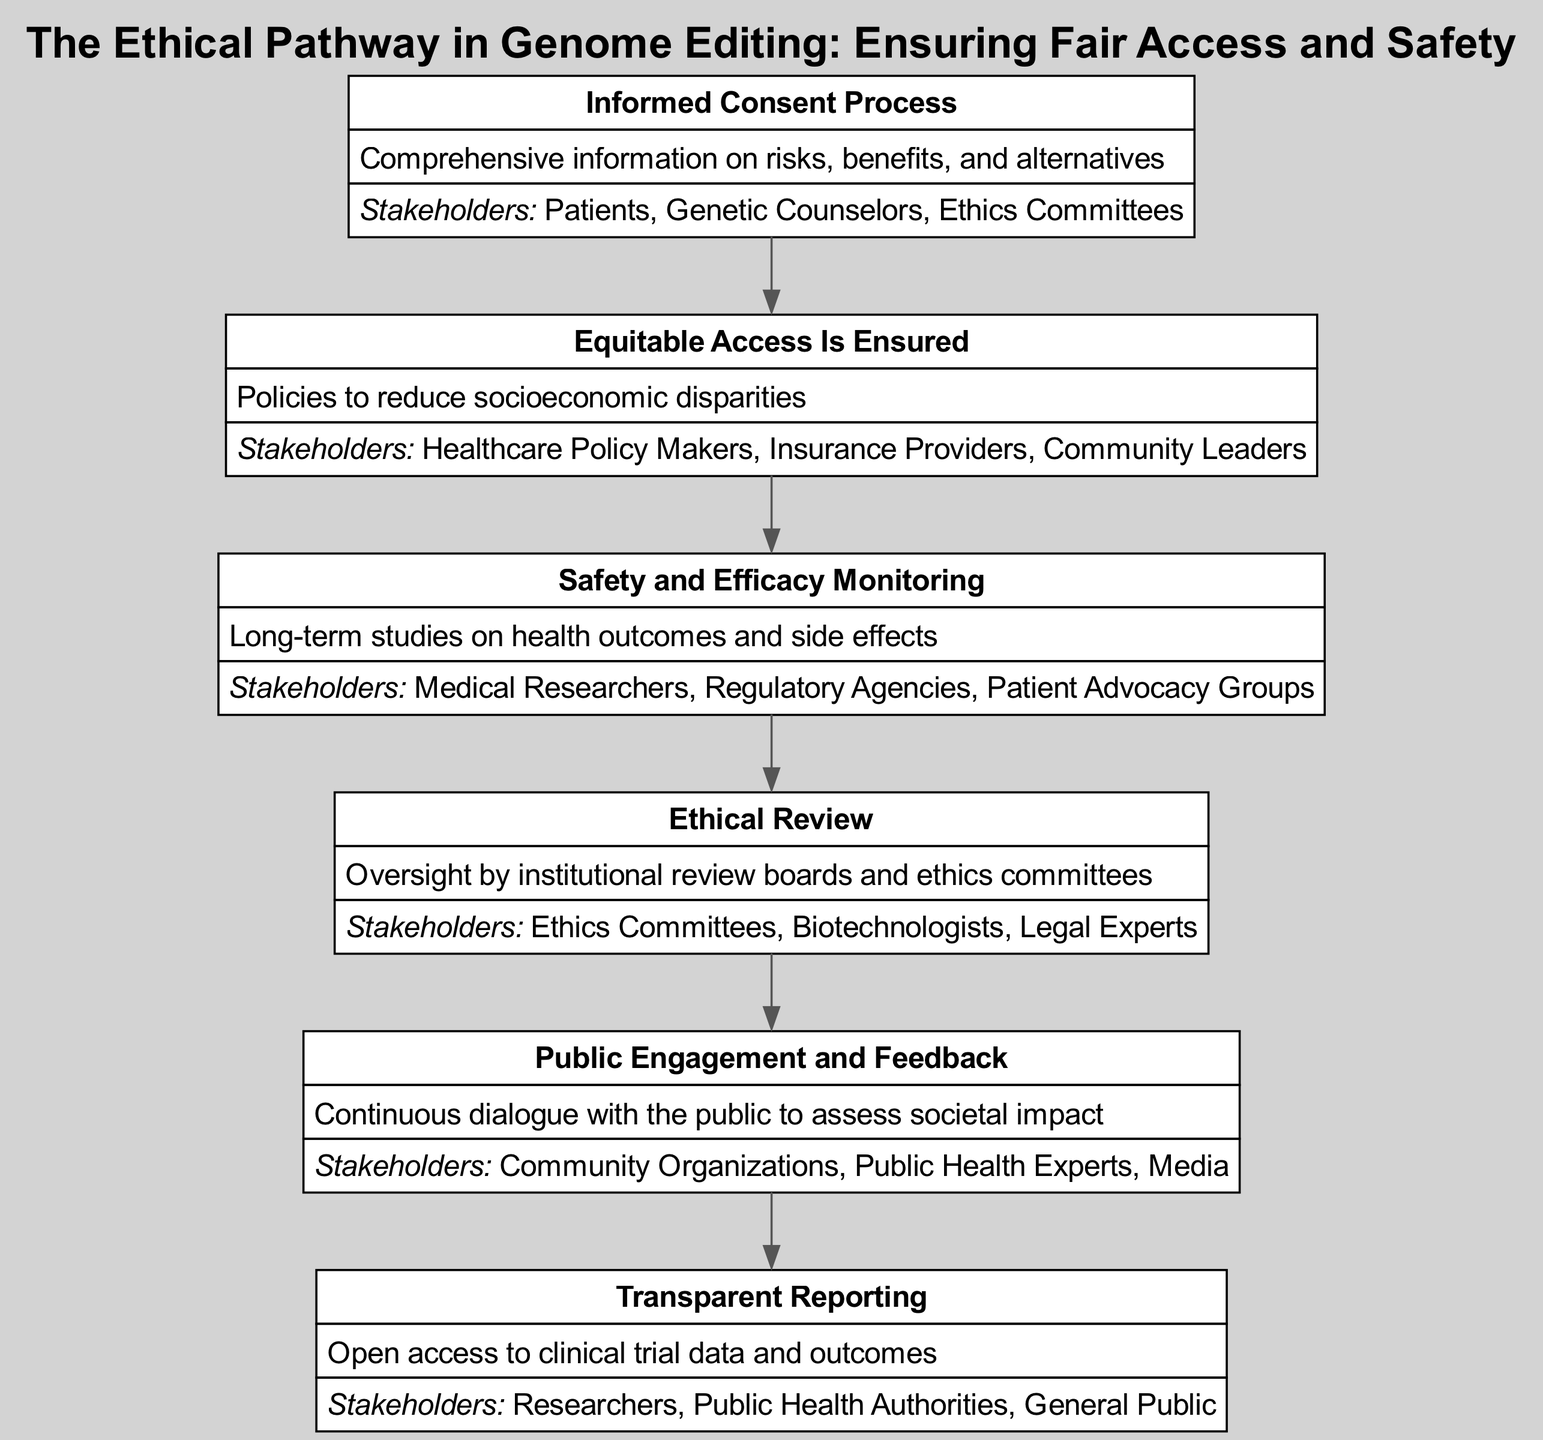What is the first node in the diagram? The first node is titled "Informed Consent Process." It serves as the initial step in the flow of the clinical pathway, which emphasizes the importance of informed consent before any genome editing procedure.
Answer: Informed Consent Process How many nodes are present in the diagram? By counting all the nodes within the diagram, we find there are six nodes in total, each representing a different element of the ethical pathway in genome editing.
Answer: 6 What is the relationship between "Equitable Access Is Ensured" and "Safety and Efficacy Monitoring"? "Equitable Access Is Ensured" is followed by "Safety and Efficacy Monitoring" in the flow of the pathway, indicating that ensuring access is a precursor to monitoring safety and efficacy in genome editing practices.
Answer: Sequential What stakeholders are involved in the "Ethical Review"? The stakeholders specifically listed for the "Ethical Review" node include Ethics Committees, Biotechnologists, and Legal Experts, indicating the range of expertise needed for ethical oversight.
Answer: Ethics Committees, Biotechnologists, Legal Experts Which node emphasizes the importance of public dialogue? The node titled "Public Engagement and Feedback" highlights the necessity of continuous dialogue with the public to assess the societal impact of genome editing practices, underlining the importance of transparency and public opinion in ethics.
Answer: Public Engagement and Feedback What step comes after "Transparent Reporting"? The pathway does not show any subsequent nodes after "Transparent Reporting," indicating it might be the final element in this clinical pathway, thereby concluding the established ethical protocols.
Answer: None What is the main aim of "Safety and Efficacy Monitoring"? The aim of "Safety and Efficacy Monitoring" is to conduct long-term studies on health outcomes and side effects, ensuring that genome editing practices are both safe and effective over time.
Answer: Long-term studies on health outcomes and side effects Who are the primary stakeholders listed for "Equitable Access Is Ensured"? The primary stakeholders involved in "Equitable Access Is Ensured" include Healthcare Policy Makers, Insurance Providers, and Community Leaders, demonstrating the collaborative effort needed to address socioeconomic disparities.
Answer: Healthcare Policy Makers, Insurance Providers, Community Leaders How does "Informed Consent Process" connect to "Transparent Reporting"? "Informed Consent Process" leads to "Equitable Access Is Ensured," which subsequently connects to "Safety and Efficacy Monitoring," and finally culminates in "Transparent Reporting." This chain illustrates the pathway from initial patient consent through to the transparent dissemination of clinical data.
Answer: Through a sequence of nodes (Informed Consent -> Equitable Access -> Safety Monitoring -> Transparent Reporting) 